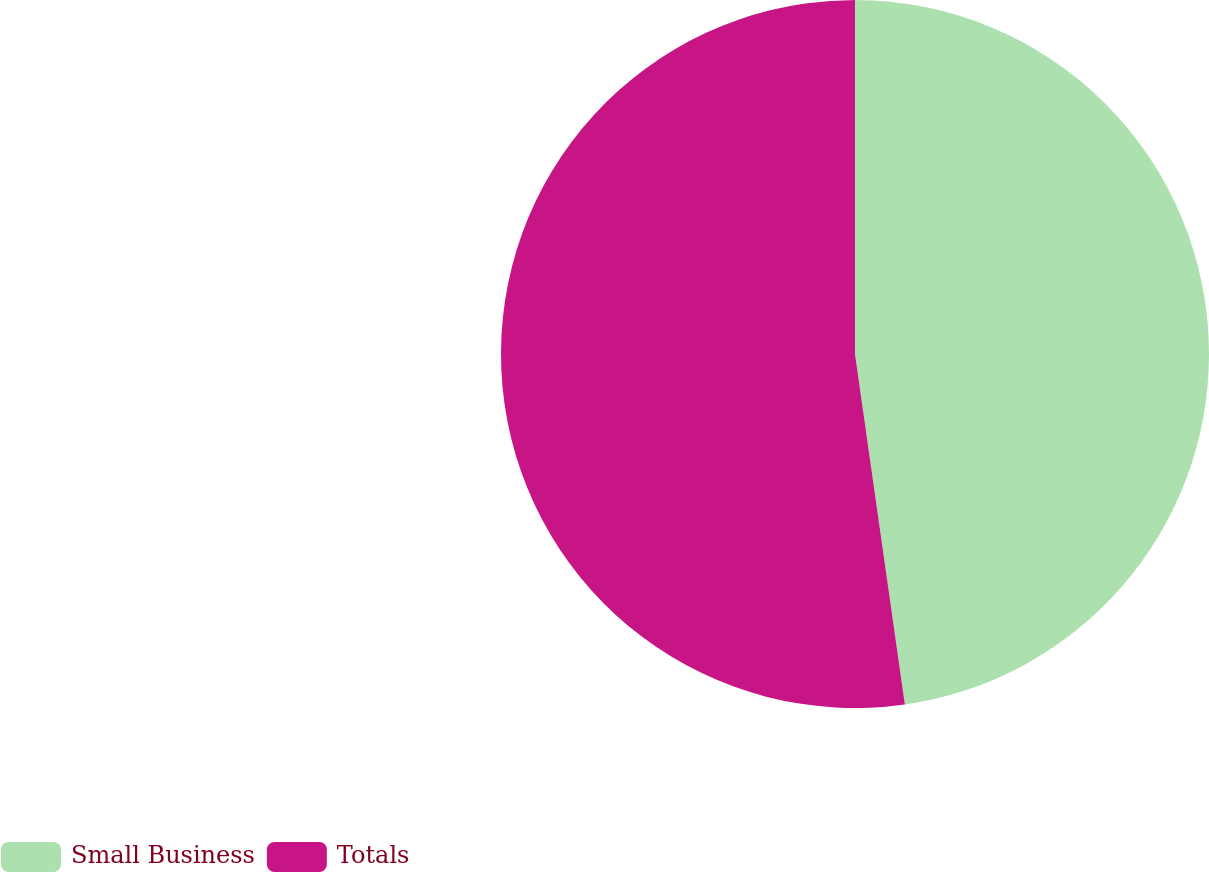Convert chart to OTSL. <chart><loc_0><loc_0><loc_500><loc_500><pie_chart><fcel>Small Business<fcel>Totals<nl><fcel>47.75%<fcel>52.25%<nl></chart> 